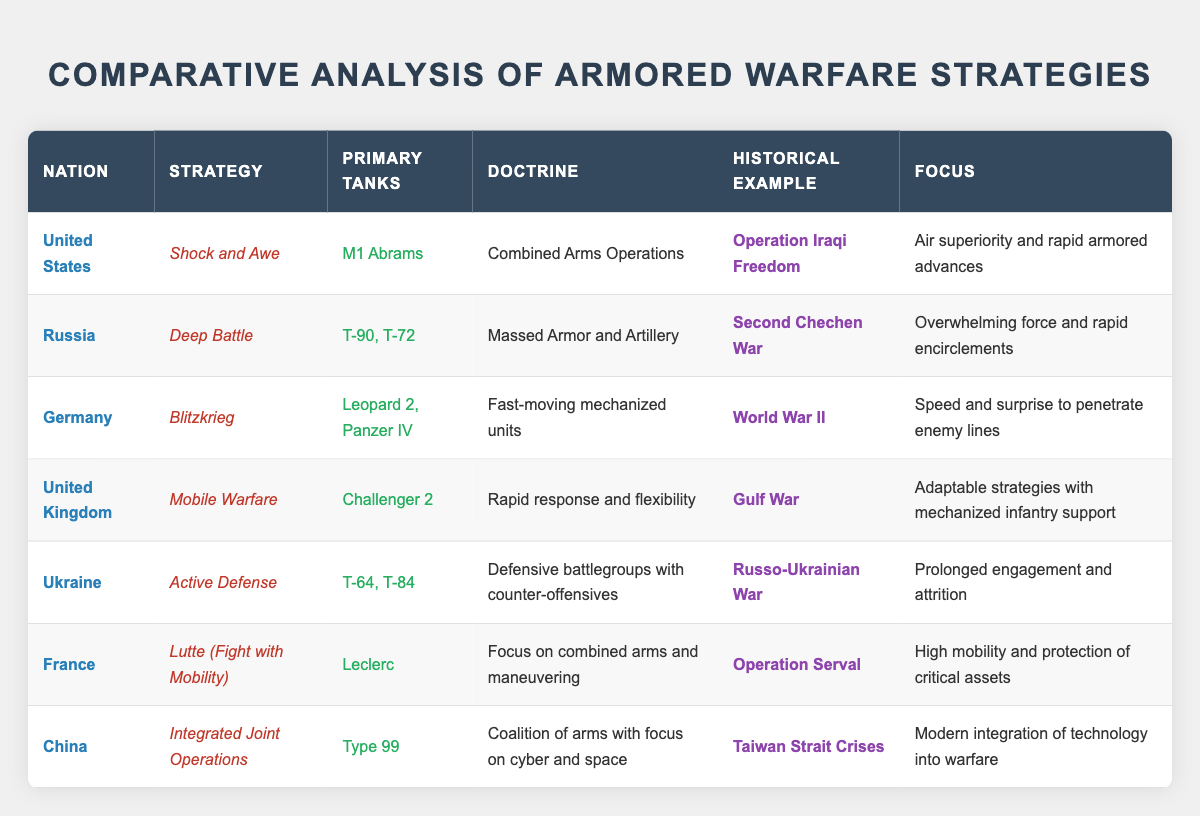What is the primary tank used by the United States? From the table, under the "Primary Tanks" column for the United States, it states "M1 Abrams."
Answer: M1 Abrams What strategy did Germany utilize during World War II? The table indicates that Germany’s strategy during World War II is "Blitzkrieg," which is noted in the "Strategy" column for that nation.
Answer: Blitzkrieg How many nations have "Deep Battle" as their strategy? In the table, only Russia is listed with the strategy "Deep Battle," making the count 1.
Answer: 1 Which nation focuses on "Air superiority and rapid armored advances"? Referring to the table, this focus is identified under the United States' entry, ensuring the answer is linked specifically to its strategy of "Shock and Awe."
Answer: United States Is the Chinese strategy focused on traditional land forces? The table specifies that China's strategy "Integrated Joint Operations" focuses on a coalition of arms with an emphasis on cyber and space, suggesting that it is not centered on traditional land forces.
Answer: No What are the two primary tanks used by Russia? By examining the "Primary Tanks" column for Russia, it lists "T-90" and "T-72;" thus, both tanks are confirmed.
Answer: T-90, T-72 Which nation has a historical example of "Operation Serval"? Looking at the "Historical Example" column, France is cited as having "Operation Serval" listed under its entry, indicating it as the nation associated with this event.
Answer: France What is the competitive focus of Ukraine's armored warfare strategy? The table details that Ukraine's strategy, "Active Defense," emphasizes "Prolonged engagement and attrition," which clarifies its competitive focus.
Answer: Prolonged engagement and attrition Do any nations utilize "Combined Arms Operations" in their strategy? The table shows that the United States implements "Combined Arms Operations" in its strategy "Shock and Awe," confirming the presence of this doctrine in armored warfare.
Answer: Yes How does the average number of primary tanks per nation compare across the table? The total count of primary tanks is 12 across 7 nations, which gives an average of 12/7 ≈ 1.71, indicating a relatively low average of primary tanks per nation.
Answer: Approximately 1.71 